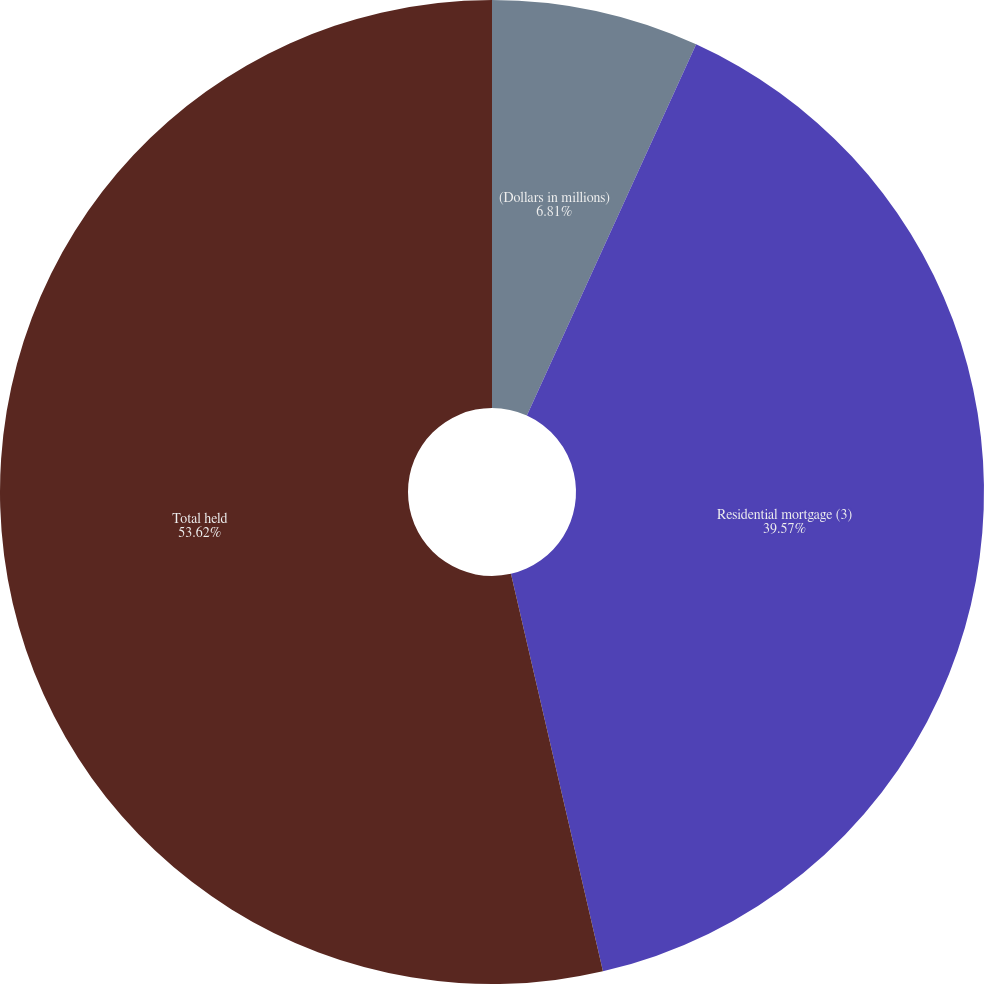Convert chart. <chart><loc_0><loc_0><loc_500><loc_500><pie_chart><fcel>(Dollars in millions)<fcel>Residential mortgage (3)<fcel>Total held<nl><fcel>6.81%<fcel>39.57%<fcel>53.62%<nl></chart> 